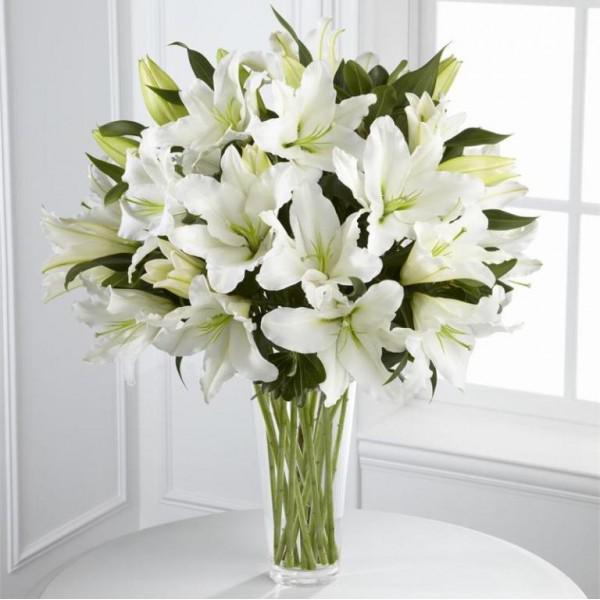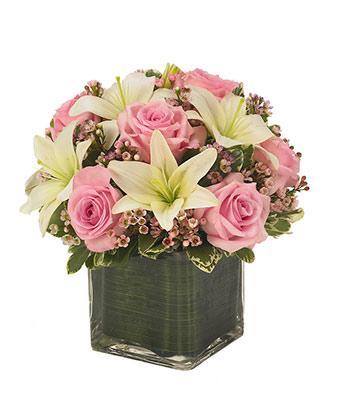The first image is the image on the left, the second image is the image on the right. Assess this claim about the two images: "One arrangement showcases white flowers and the other contains pink flowers.". Correct or not? Answer yes or no. Yes. 